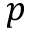Convert formula to latex. <formula><loc_0><loc_0><loc_500><loc_500>p</formula> 